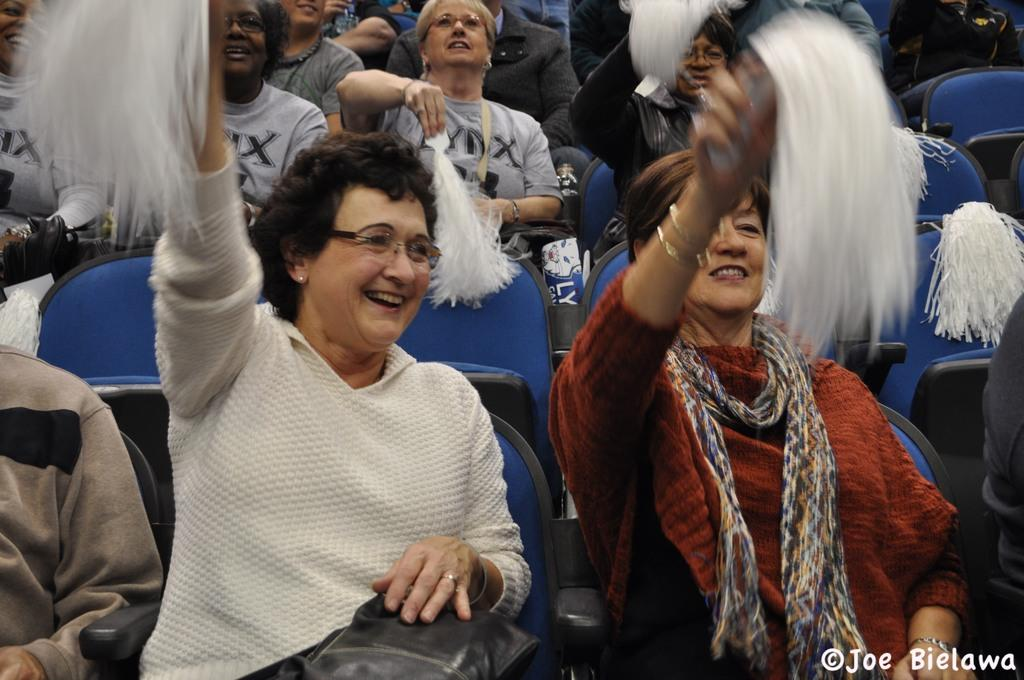Who or what is present in the image? There are people in the image. What are the people doing in the image? The people are sitting on chairs. What objects are the people holding in their hands? The people are holding pom poms in their hands. How many nails can be seen in the image? There are no nails present in the image. 